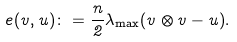<formula> <loc_0><loc_0><loc_500><loc_500>e ( v , u ) \colon = \frac { n } { 2 } \lambda _ { \max } ( v \otimes v - u ) .</formula> 